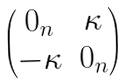Convert formula to latex. <formula><loc_0><loc_0><loc_500><loc_500>\begin{pmatrix} 0 _ { n } & \kappa \\ - \kappa & 0 _ { n } \end{pmatrix}</formula> 